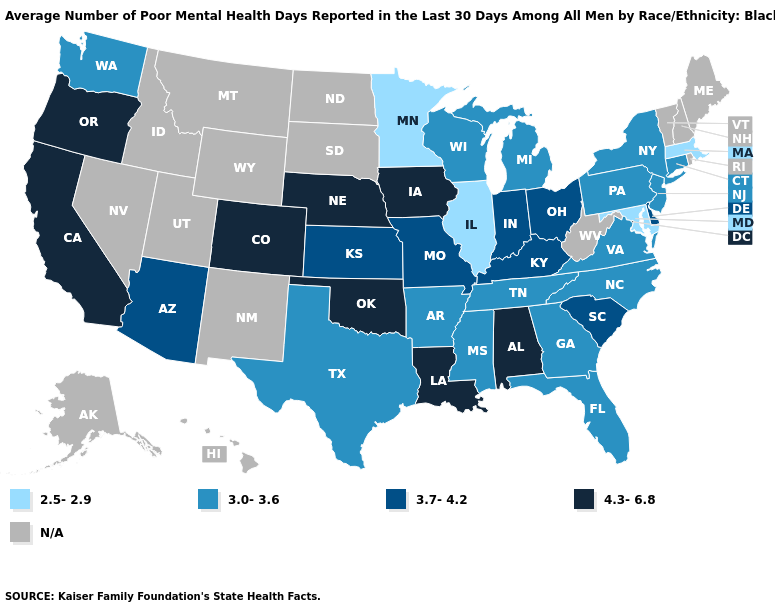What is the highest value in the USA?
Quick response, please. 4.3-6.8. What is the value of New York?
Give a very brief answer. 3.0-3.6. What is the value of Kansas?
Keep it brief. 3.7-4.2. What is the value of Hawaii?
Keep it brief. N/A. Name the states that have a value in the range 3.0-3.6?
Give a very brief answer. Arkansas, Connecticut, Florida, Georgia, Michigan, Mississippi, New Jersey, New York, North Carolina, Pennsylvania, Tennessee, Texas, Virginia, Washington, Wisconsin. Does the first symbol in the legend represent the smallest category?
Quick response, please. Yes. Which states have the lowest value in the USA?
Concise answer only. Illinois, Maryland, Massachusetts, Minnesota. What is the highest value in the South ?
Short answer required. 4.3-6.8. What is the highest value in the USA?
Write a very short answer. 4.3-6.8. Among the states that border Oregon , does Washington have the highest value?
Answer briefly. No. What is the highest value in the USA?
Write a very short answer. 4.3-6.8. What is the highest value in states that border Oregon?
Keep it brief. 4.3-6.8. Does Iowa have the highest value in the USA?
Give a very brief answer. Yes. 